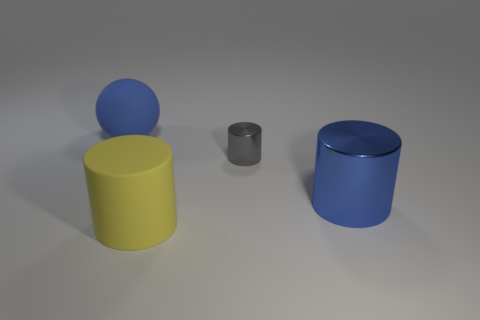Subtract all small metallic cylinders. How many cylinders are left? 2 Add 4 gray cylinders. How many objects exist? 8 Subtract all cylinders. How many objects are left? 1 Add 4 big rubber cylinders. How many big rubber cylinders are left? 5 Add 1 yellow objects. How many yellow objects exist? 2 Subtract 0 blue blocks. How many objects are left? 4 Subtract all cyan cylinders. Subtract all purple spheres. How many cylinders are left? 3 Subtract all tiny gray objects. Subtract all cylinders. How many objects are left? 0 